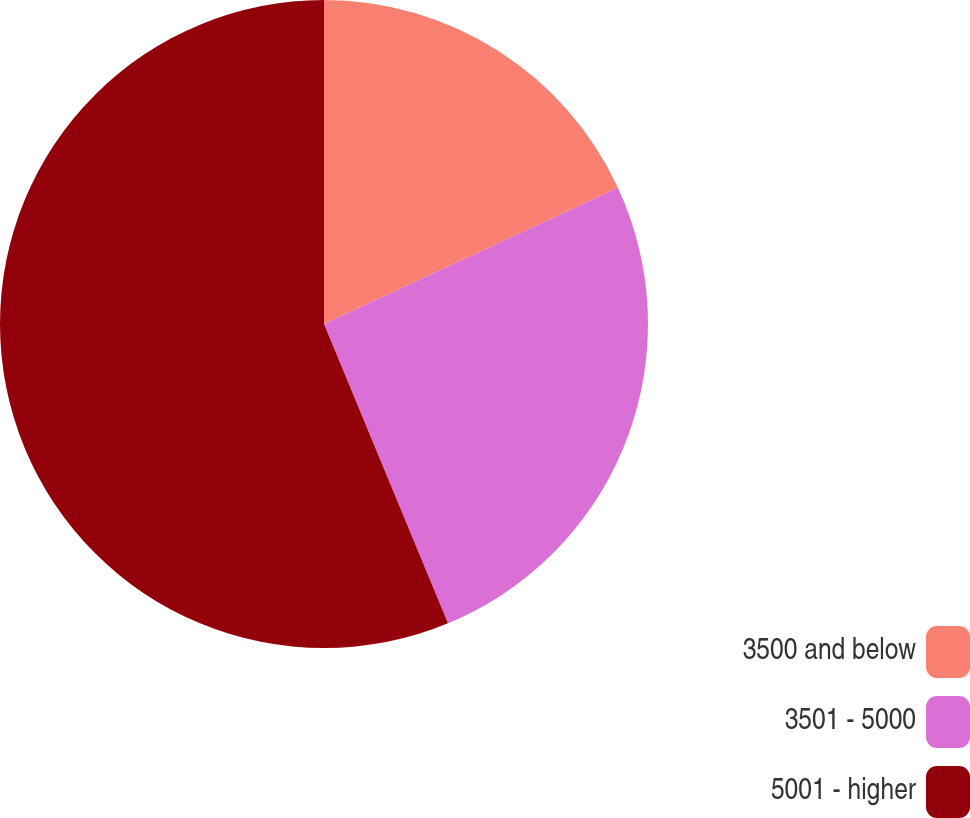<chart> <loc_0><loc_0><loc_500><loc_500><pie_chart><fcel>3500 and below<fcel>3501 - 5000<fcel>5001 - higher<nl><fcel>18.09%<fcel>25.66%<fcel>56.25%<nl></chart> 